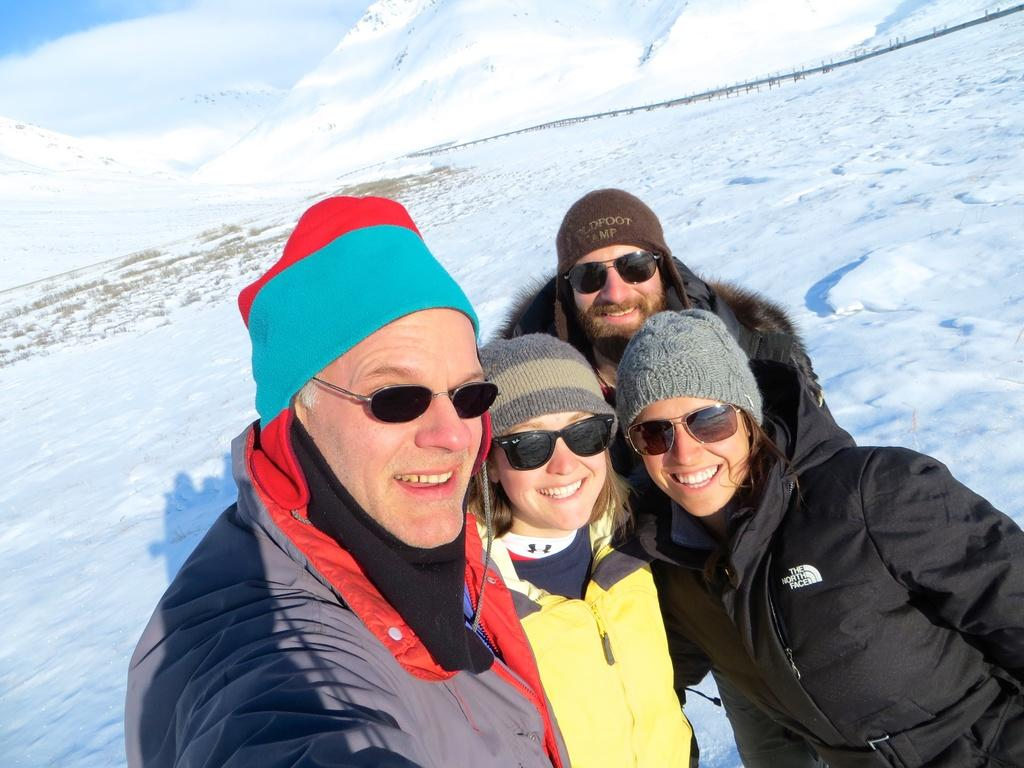How many people are in the image? There are people in the image, but the exact number is not specified. What is the facial expression of the people in the image? The people in the image are smiling. What type of clothing are the people wearing? The people are wearing jackets, caps, and goggles. What can be seen in the background of the image? There is snow and the sky visible in the background of the image. What type of houses can be seen in the image? There are no houses present in the image. What is the tax rate for the area depicted in the image? The facts provided do not mention any information about tax rates, so it cannot be determined from the image. 